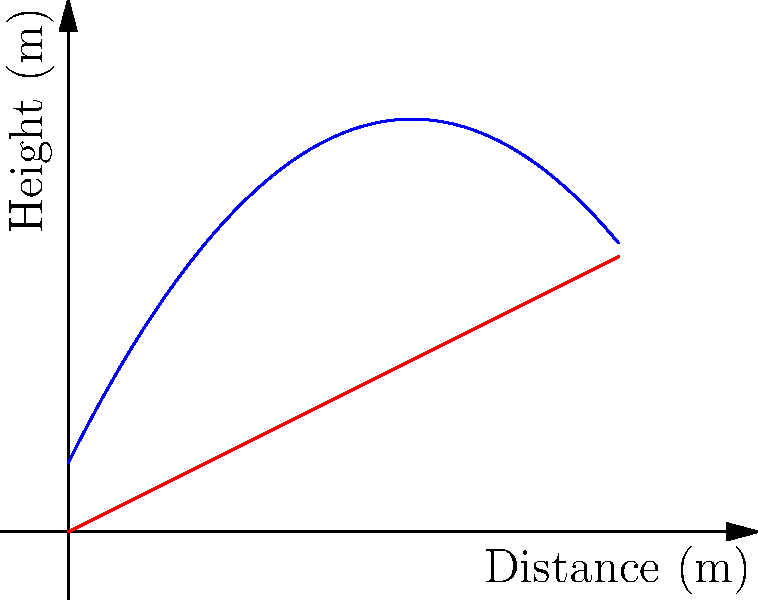As a sports analyst with experience in women's football, consider the parabolic trajectory of a football kick represented by the function $f(x) = -0.2x^2 + 2x + 1$, where $x$ is the horizontal distance in meters and $f(x)$ is the height in meters. The ground is represented by the function $g(x) = 0.5x$. At what horizontal distance does the ball land? To find the landing point, we need to follow these steps:

1) The ball lands when the height of the ball equals the height of the ground. Mathematically, this occurs when $f(x) = g(x)$.

2) Let's set up the equation:
   $-0.2x^2 + 2x + 1 = 0.5x$

3) Rearrange the equation:
   $-0.2x^2 + 1.5x + 1 = 0$

4) This is a quadratic equation in the form $ax^2 + bx + c = 0$, where:
   $a = -0.2$
   $b = 1.5$
   $c = 1$

5) We can solve this using the quadratic formula: $x = \frac{-b \pm \sqrt{b^2 - 4ac}}{2a}$

6) Substituting our values:
   $x = \frac{-1.5 \pm \sqrt{1.5^2 - 4(-0.2)(1)}}{2(-0.2)}$

7) Simplifying:
   $x = \frac{-1.5 \pm \sqrt{2.25 + 0.8}}{-0.4} = \frac{-1.5 \pm \sqrt{3.05}}{-0.4}$

8) This gives us two solutions:
   $x \approx 7.45$ or $x \approx 0.05$

9) Since we're interested in where the ball lands after being kicked, we choose the larger value.

Therefore, the ball lands at approximately 7.45 meters from the kick point.
Answer: 7.45 meters 